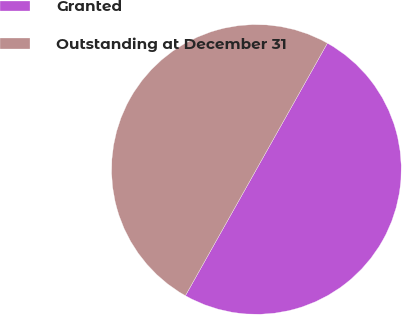Convert chart to OTSL. <chart><loc_0><loc_0><loc_500><loc_500><pie_chart><fcel>Granted<fcel>Outstanding at December 31<nl><fcel>50.0%<fcel>50.0%<nl></chart> 